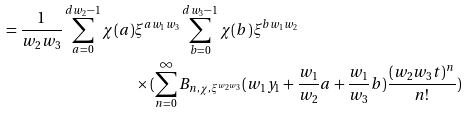<formula> <loc_0><loc_0><loc_500><loc_500>= \frac { 1 } { w _ { 2 } w _ { 3 } } \sum _ { a = 0 } ^ { d w _ { 2 } - 1 } \chi ( a ) & \xi ^ { a w _ { 1 } w _ { 3 } } \sum _ { b = 0 } ^ { d w _ { 3 } - 1 } \chi ( b ) \xi ^ { b w _ { 1 } w _ { 2 } } \\ & \times ( \sum _ { n = 0 } ^ { \infty } B _ { n , \chi , \xi ^ { w _ { 2 } w _ { 3 } } } ( w _ { 1 } y _ { 1 } + \frac { w _ { 1 } } { w _ { 2 } } a + \frac { w _ { 1 } } { w _ { 3 } } b ) \frac { ( w _ { 2 } w _ { 3 } t ) ^ { n } } { n ! } )</formula> 